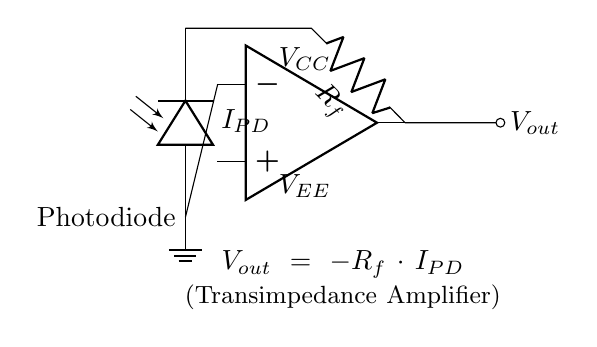What component converts light to current in this circuit? The photodiode is the component that converts incoming light into an electrical current, represented as I_PD in the circuit.
Answer: Photodiode What is the function of the feedback resistor in this circuit? The feedback resistor R_f determines the gain of the transimpedance amplifier, allowing it to convert the input current from the photodiode into an output voltage based on the relationship V_out = -R_f * I_PD.
Answer: Gain What is the polarity of the output voltage with respect to the input current? The output voltage V_out is inverted compared to the input current from the photodiode, as indicated by the negative sign in the equation V_out = -R_f * I_PD.
Answer: Inverted Which node is connected to ground in the circuit? The negative input of the operational amplifier is connected directly to ground, providing a reference point for the circuit's operation.
Answer: Op amp negative input If I_PD is 2 microamperes and R_f is 1 megaohm, what is V_out? According to the equation V_out = -R_f * I_PD, substituting the values gives V_out = -1 MΩ * 2 µA = -2 volts. Therefore, the output voltage is calculated as negative two volts.
Answer: Negative two volts What happens to V_out if the current I_PD increases? If the current I_PD increases, V_out becomes more negative due to the product of the feedback resistor R_f and I_PD, leading to a larger negative voltage (due to the amplification).
Answer: More negative 